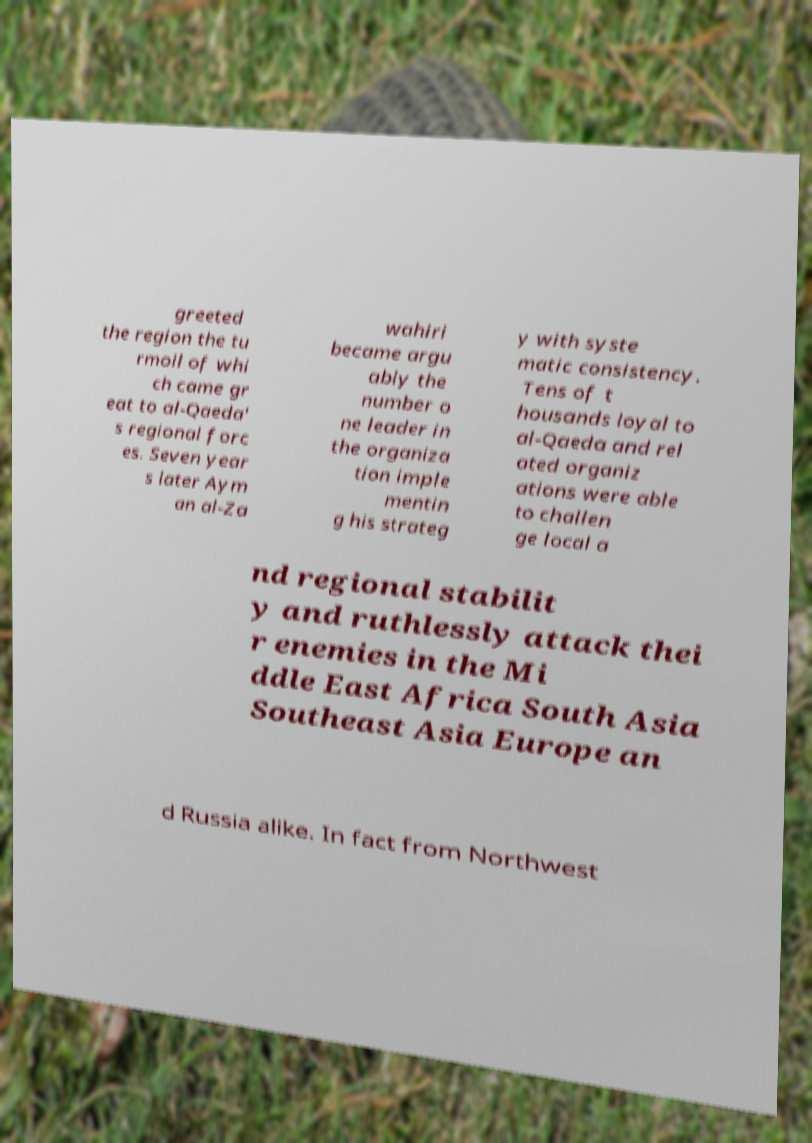There's text embedded in this image that I need extracted. Can you transcribe it verbatim? greeted the region the tu rmoil of whi ch came gr eat to al-Qaeda' s regional forc es. Seven year s later Aym an al-Za wahiri became argu ably the number o ne leader in the organiza tion imple mentin g his strateg y with syste matic consistency. Tens of t housands loyal to al-Qaeda and rel ated organiz ations were able to challen ge local a nd regional stabilit y and ruthlessly attack thei r enemies in the Mi ddle East Africa South Asia Southeast Asia Europe an d Russia alike. In fact from Northwest 